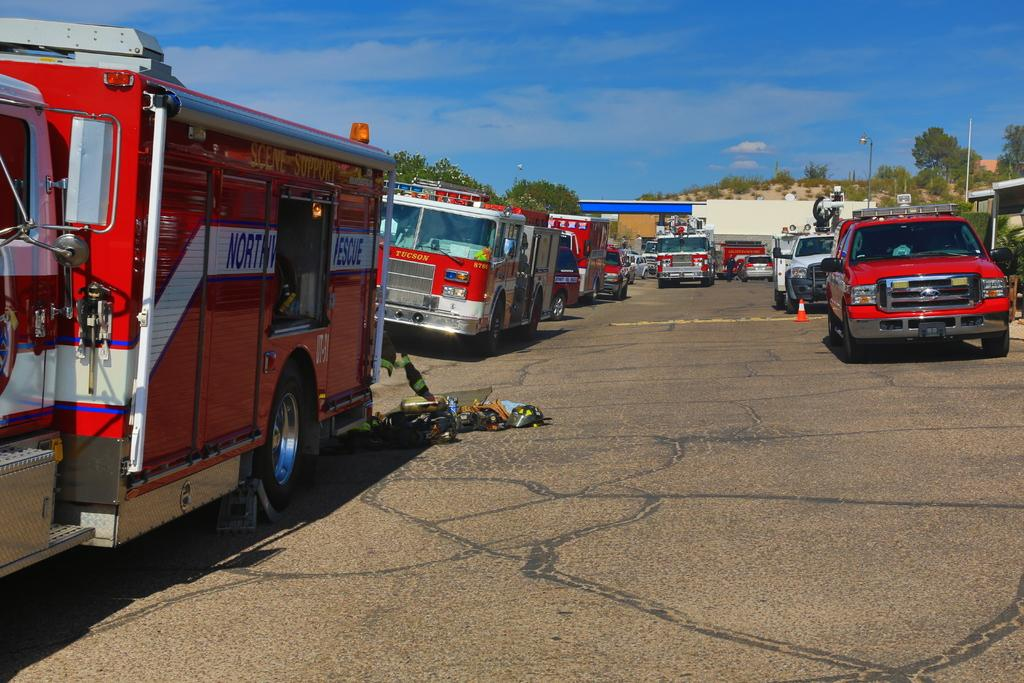What types of objects can be seen in the image? There are vehicles in the image. What can be seen in the distance behind the vehicles? There are buildings, trees, and poles in the background of the image. How many legs can be seen on the furniture in the image? There is no furniture present in the image, so it is not possible to determine the number of legs. 